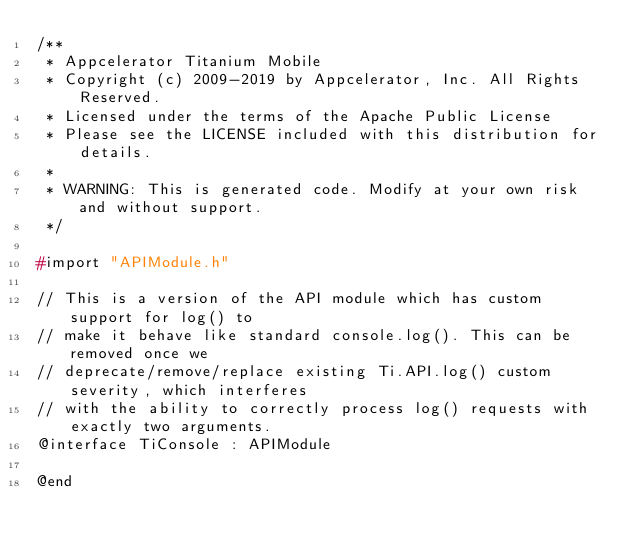Convert code to text. <code><loc_0><loc_0><loc_500><loc_500><_C_>/**
 * Appcelerator Titanium Mobile
 * Copyright (c) 2009-2019 by Appcelerator, Inc. All Rights Reserved.
 * Licensed under the terms of the Apache Public License
 * Please see the LICENSE included with this distribution for details.
 * 
 * WARNING: This is generated code. Modify at your own risk and without support.
 */

#import "APIModule.h"

// This is a version of the API module which has custom support for log() to
// make it behave like standard console.log(). This can be removed once we
// deprecate/remove/replace existing Ti.API.log() custom severity, which interferes
// with the ability to correctly process log() requests with exactly two arguments.
@interface TiConsole : APIModule

@end
</code> 